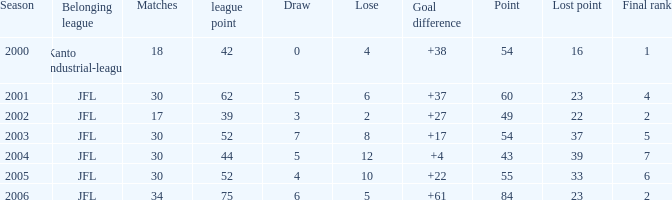Would you mind parsing the complete table? {'header': ['Season', 'Belonging league', 'Matches', 'league point', 'Draw', 'Lose', 'Goal difference', 'Point', 'Lost point', 'Final rank'], 'rows': [['2000', 'Kanto industrial-league', '18', '42', '0', '4', '+38', '54', '16', '1'], ['2001', 'JFL', '30', '62', '5', '6', '+37', '60', '23', '4'], ['2002', 'JFL', '17', '39', '3', '2', '+27', '49', '22', '2'], ['2003', 'JFL', '30', '52', '7', '8', '+17', '54', '37', '5'], ['2004', 'JFL', '30', '44', '5', '12', '+4', '43', '39', '7'], ['2005', 'JFL', '30', '52', '4', '10', '+22', '55', '33', '6'], ['2006', 'JFL', '34', '75', '6', '5', '+61', '84', '23', '2']]} What is the mean final position for loe exceeding 10 and score below 43? None. 